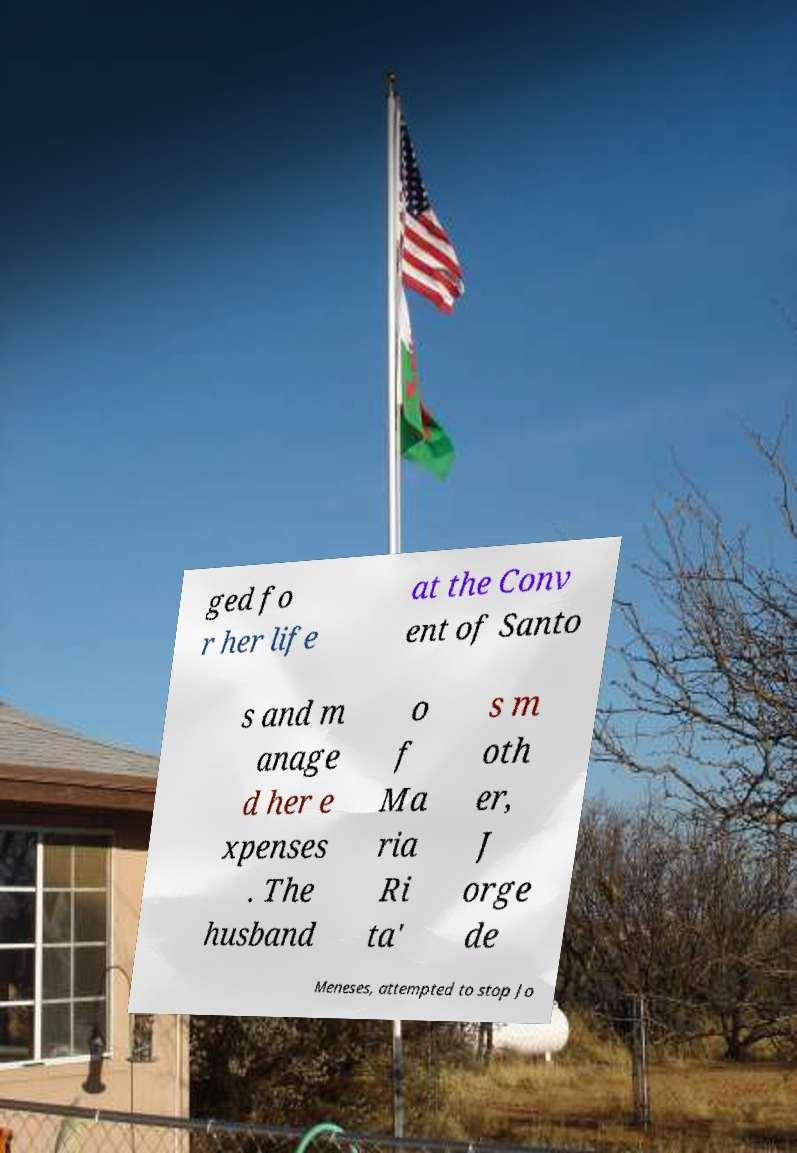What messages or text are displayed in this image? I need them in a readable, typed format. ged fo r her life at the Conv ent of Santo s and m anage d her e xpenses . The husband o f Ma ria Ri ta' s m oth er, J orge de Meneses, attempted to stop Jo 